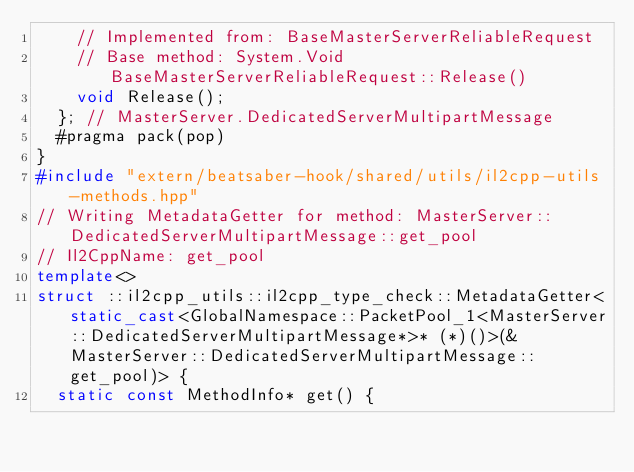<code> <loc_0><loc_0><loc_500><loc_500><_C++_>    // Implemented from: BaseMasterServerReliableRequest
    // Base method: System.Void BaseMasterServerReliableRequest::Release()
    void Release();
  }; // MasterServer.DedicatedServerMultipartMessage
  #pragma pack(pop)
}
#include "extern/beatsaber-hook/shared/utils/il2cpp-utils-methods.hpp"
// Writing MetadataGetter for method: MasterServer::DedicatedServerMultipartMessage::get_pool
// Il2CppName: get_pool
template<>
struct ::il2cpp_utils::il2cpp_type_check::MetadataGetter<static_cast<GlobalNamespace::PacketPool_1<MasterServer::DedicatedServerMultipartMessage*>* (*)()>(&MasterServer::DedicatedServerMultipartMessage::get_pool)> {
  static const MethodInfo* get() {</code> 